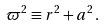Convert formula to latex. <formula><loc_0><loc_0><loc_500><loc_500>\varpi ^ { 2 } \equiv r ^ { 2 } + a ^ { 2 } \, .</formula> 